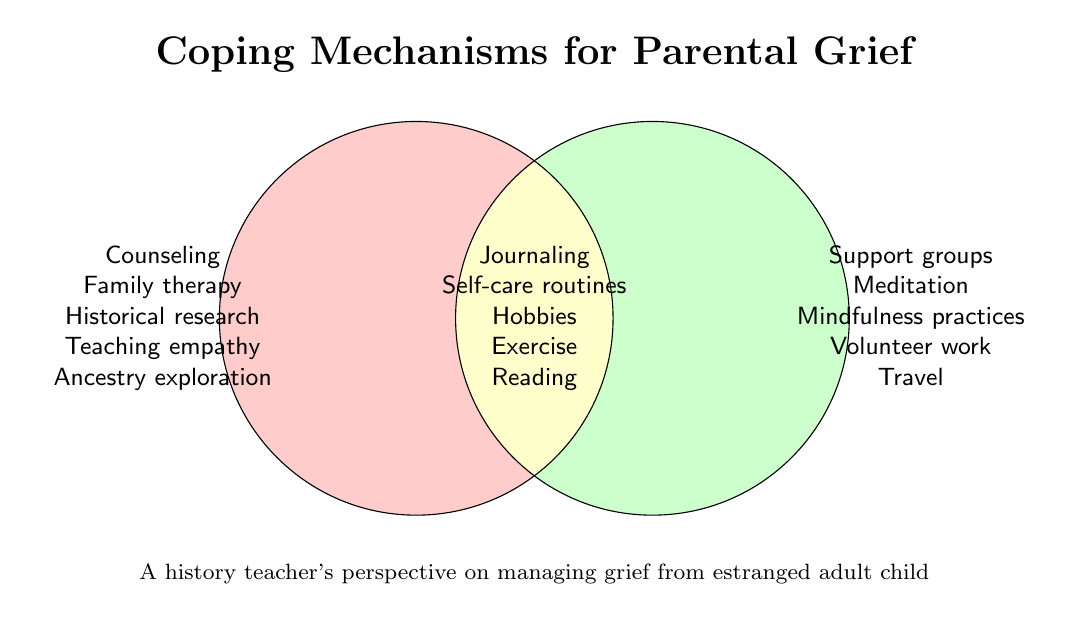What is the title of the Venn Diagram? The title is located at the top of the Venn Diagram. It reads "Coping Mechanisms for Parental Grief".
Answer: Coping Mechanisms for Parental Grief What is shared between the two sets in the Venn Diagram? The shared elements are found in the intersection area of the Venn Diagram. They are "Journaling", "Self-care routines", "Hobbies", "Exercise", and "Reading".
Answer: Journaling, Self-care routines, Hobbies, Exercise, Reading How many coping mechanisms are exclusive to Set 1? Exclusive elements to Set 1 are listed on the left circle but are not in the intersection. They include "Counseling", "Family therapy", "Historical research", "Teaching empathy", and "Ancestry exploration".
Answer: 5 Which coping mechanisms are unique to Set 2? Unique elements to Set 2 are listed on the right circle without overlapping the intersection. They are "Support groups", "Meditation", "Mindfulness practices", "Volunteer work", and "Travel".
Answer: Support groups, Meditation, Mindfulness practices, Volunteer work, Travel Which circle lists "Mindfulness practices"? "Mindfulness practices" is listed in the right circle, which represents Set 2.
Answer: Set 2 Are there more coping mechanisms in the intersection or in Set 1's exclusive values? The intersection has 5 elements, and Set 1's exclusive values also have 5 elements. Both have an equal number.
Answer: Equal Is "Journaling" a shared coping mechanism or unique to one set? "Journaling" appears in the intersection between the two sets, indicating it is a shared coping mechanism.
Answer: Shared Which group has "Historical research"? "Historical research" is found in the left circle, which represents Set 1.
Answer: Set 1 